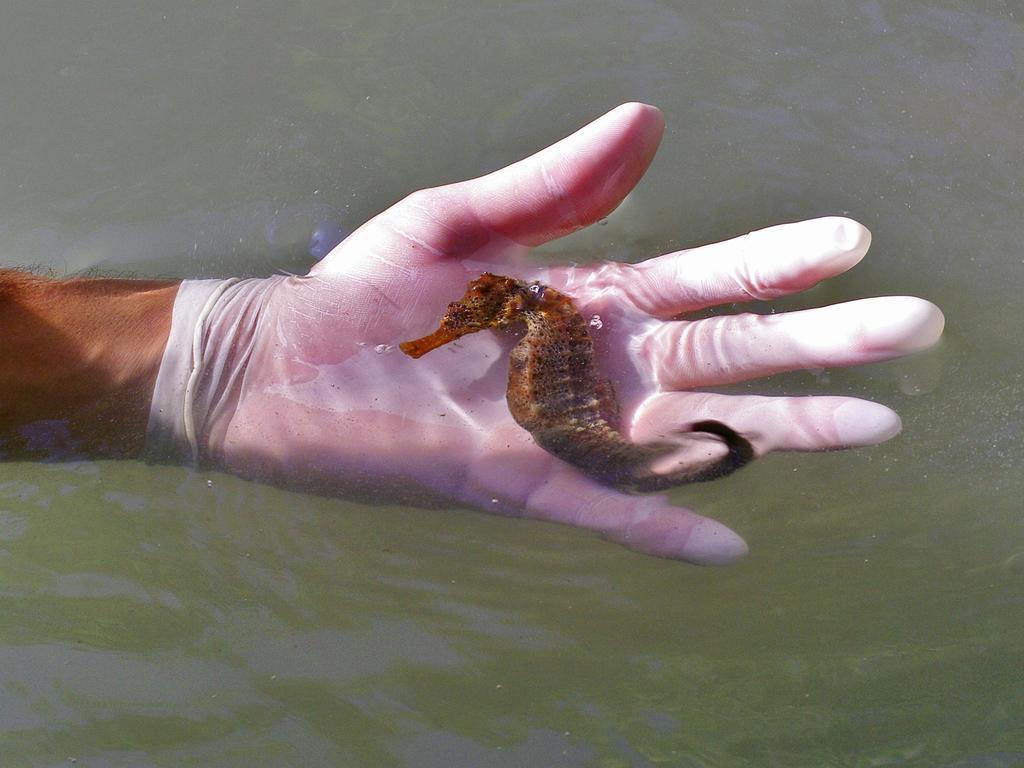Can you describe this image briefly? In the center of this picture we can see the hand of a person wearing a glove and holding a seahorse. In the background we can see a water body. 